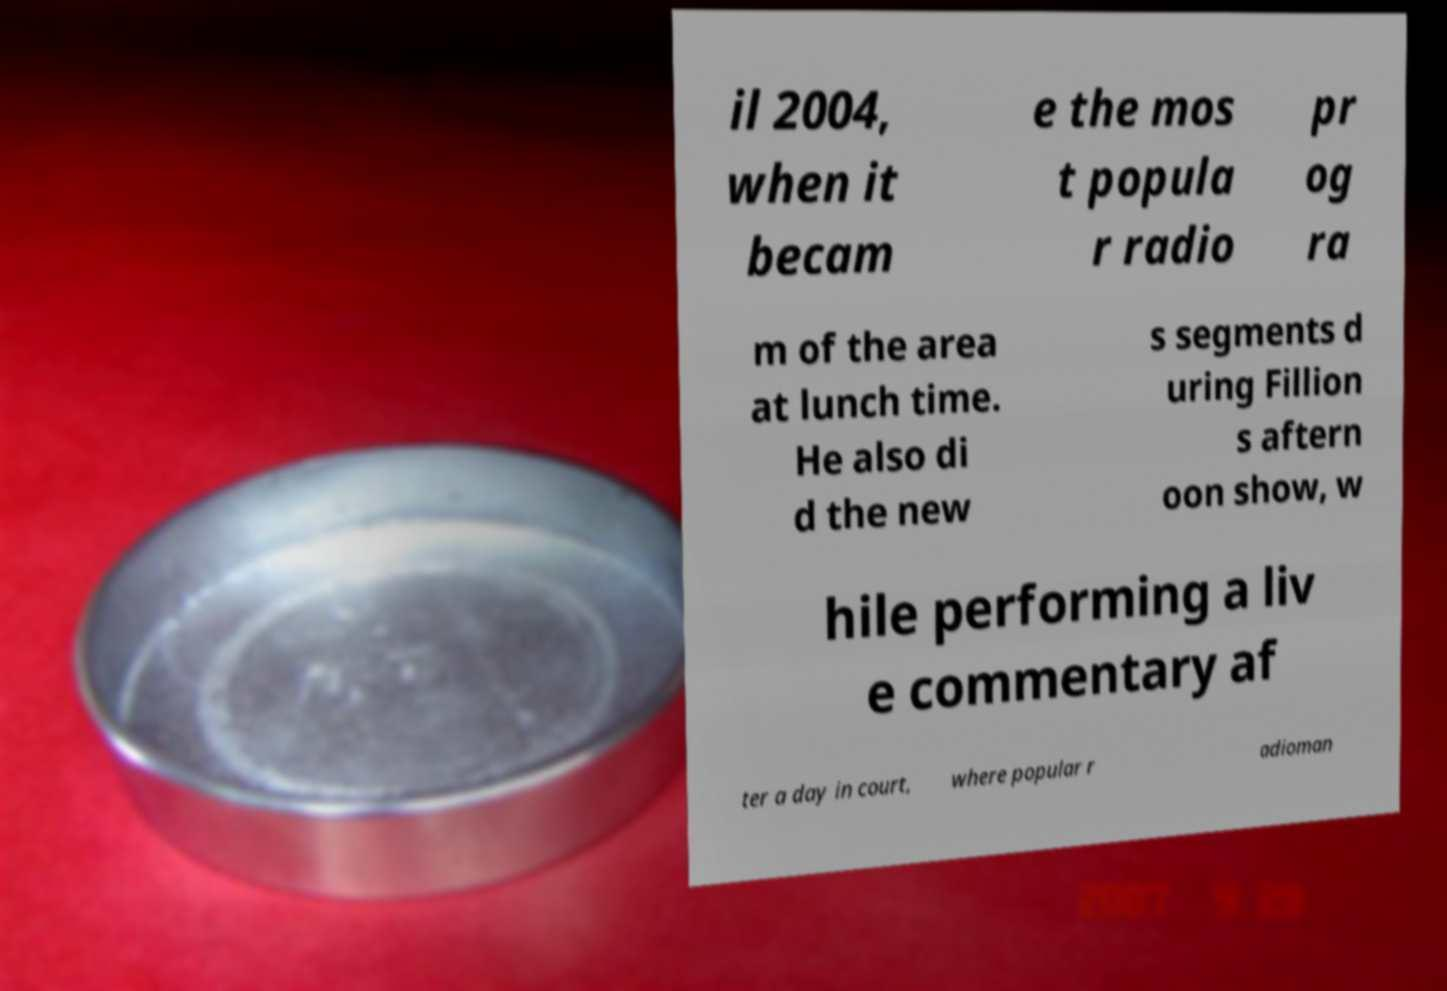Please identify and transcribe the text found in this image. il 2004, when it becam e the mos t popula r radio pr og ra m of the area at lunch time. He also di d the new s segments d uring Fillion s aftern oon show, w hile performing a liv e commentary af ter a day in court, where popular r adioman 